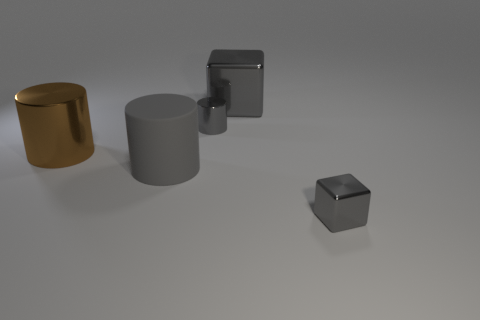Subtract all blue cylinders. Subtract all green spheres. How many cylinders are left? 3 Add 5 gray rubber objects. How many objects exist? 10 Subtract all cylinders. How many objects are left? 2 Add 2 gray blocks. How many gray blocks are left? 4 Add 1 gray shiny objects. How many gray shiny objects exist? 4 Subtract 0 red cylinders. How many objects are left? 5 Subtract all tiny gray things. Subtract all big brown cylinders. How many objects are left? 2 